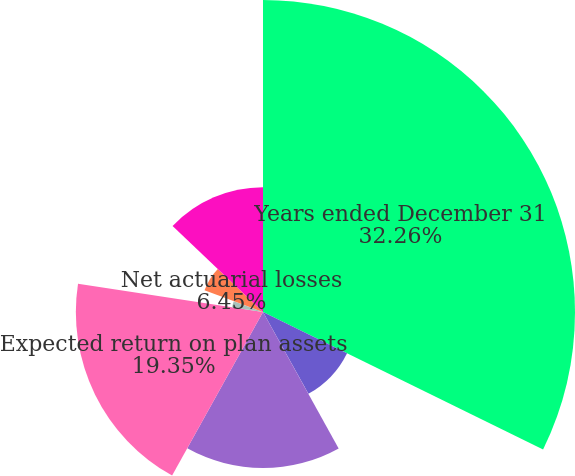<chart> <loc_0><loc_0><loc_500><loc_500><pie_chart><fcel>Years ended December 31<fcel>Service cost<fcel>Interest cost<fcel>Expected return on plan assets<fcel>Settlement and curtailment<fcel>Prior service cost (credit)<fcel>Net actuarial losses<fcel>Net periodic cost<nl><fcel>32.26%<fcel>9.68%<fcel>16.13%<fcel>19.35%<fcel>3.23%<fcel>0.0%<fcel>6.45%<fcel>12.9%<nl></chart> 